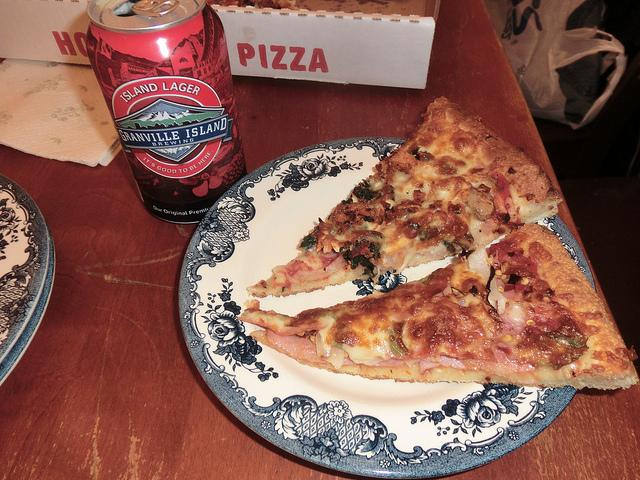What kind of beverage is being enjoyed with the pizza? beer 